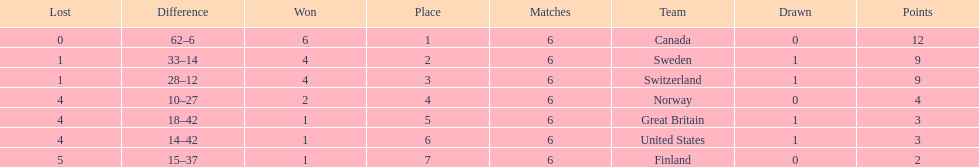How many teams won at least 2 games throughout the 1951 world ice hockey championships? 4. 